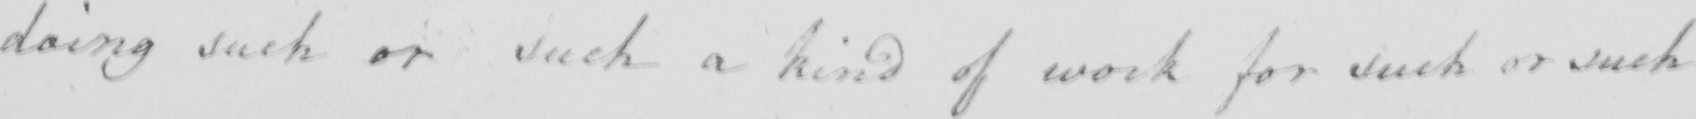What is written in this line of handwriting? doing such or such a kind of work for such or such 